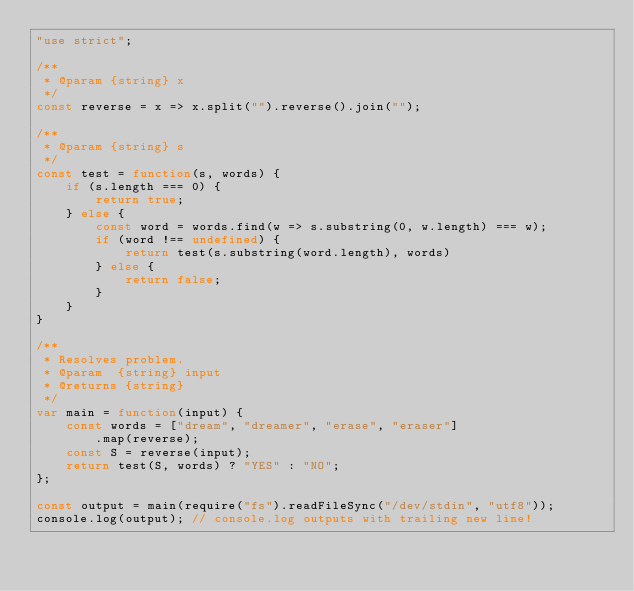<code> <loc_0><loc_0><loc_500><loc_500><_JavaScript_>"use strict";

/**
 * @param {string} x 
 */
const reverse = x => x.split("").reverse().join("");

/**
 * @param {string} s 
 */
const test = function(s, words) {
    if (s.length === 0) {
        return true;
    } else {
        const word = words.find(w => s.substring(0, w.length) === w);
        if (word !== undefined) {
            return test(s.substring(word.length), words)
        } else {
            return false;
        }
    }
}

/**
 * Resolves problem.
 * @param  {string} input
 * @returns {string}
 */
var main = function(input) {
    const words = ["dream", "dreamer", "erase", "eraser"]
        .map(reverse);
    const S = reverse(input);
    return test(S, words) ? "YES" : "NO";
};

const output = main(require("fs").readFileSync("/dev/stdin", "utf8"));
console.log(output); // console.log outputs with trailing new line!
</code> 